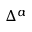<formula> <loc_0><loc_0><loc_500><loc_500>\Delta ^ { \alpha }</formula> 